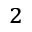<formula> <loc_0><loc_0><loc_500><loc_500>_ { 2 }</formula> 